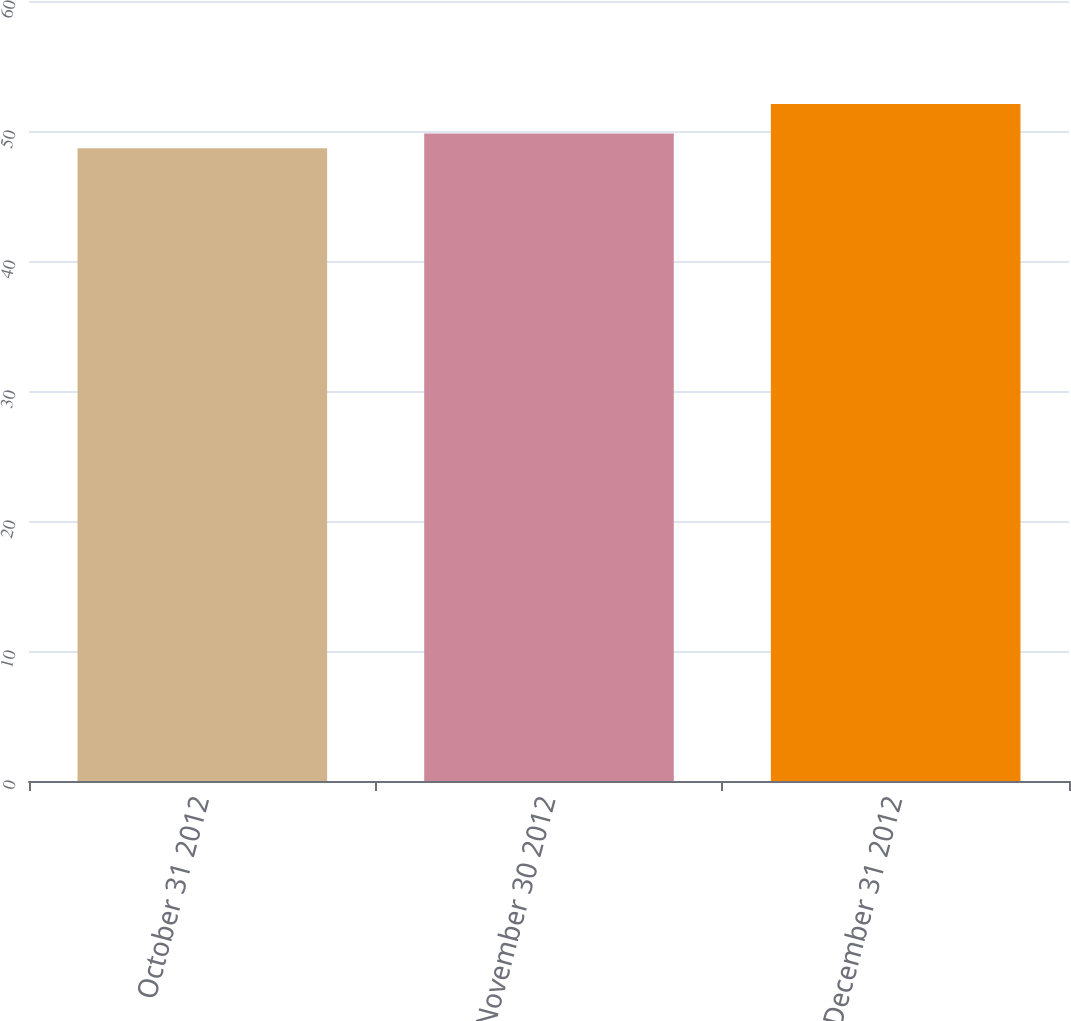Convert chart to OTSL. <chart><loc_0><loc_0><loc_500><loc_500><bar_chart><fcel>October 31 2012<fcel>November 30 2012<fcel>December 31 2012<nl><fcel>48.67<fcel>49.81<fcel>52.07<nl></chart> 